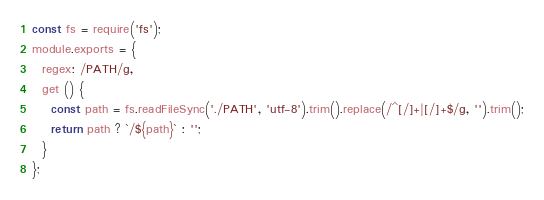Convert code to text. <code><loc_0><loc_0><loc_500><loc_500><_JavaScript_>
const fs = require('fs');
module.exports = {
  regex: /PATH/g,
  get () {
    const path = fs.readFileSync('./PATH', 'utf-8').trim().replace(/^[/]+|[/]+$/g, '').trim();
    return path ? `/${path}` : '';
  }
};</code> 